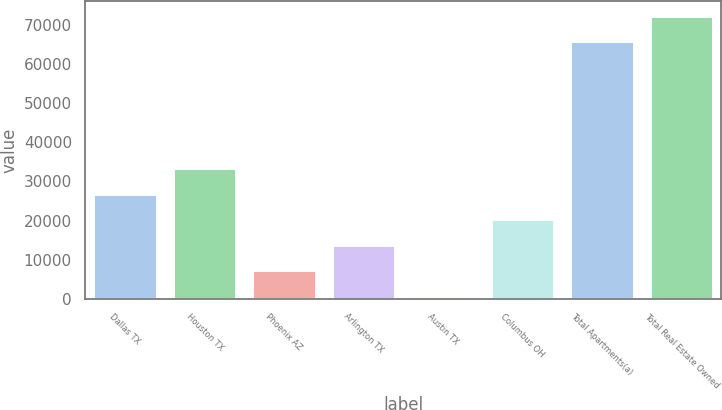Convert chart. <chart><loc_0><loc_0><loc_500><loc_500><bar_chart><fcel>Dallas TX<fcel>Houston TX<fcel>Phoenix AZ<fcel>Arlington TX<fcel>Austin TX<fcel>Columbus OH<fcel>Total Apartments(a)<fcel>Total Real Estate Owned<nl><fcel>26822<fcel>33329.5<fcel>7299.5<fcel>13807<fcel>792<fcel>20314.5<fcel>65867<fcel>72374.5<nl></chart> 